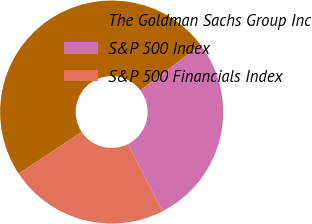Convert chart. <chart><loc_0><loc_0><loc_500><loc_500><pie_chart><fcel>The Goldman Sachs Group Inc<fcel>S&P 500 Index<fcel>S&P 500 Financials Index<nl><fcel>49.06%<fcel>27.75%<fcel>23.2%<nl></chart> 